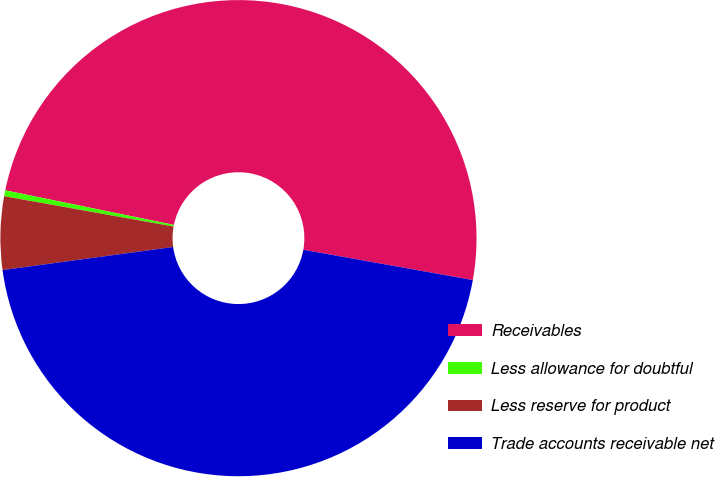<chart> <loc_0><loc_0><loc_500><loc_500><pie_chart><fcel>Receivables<fcel>Less allowance for doubtful<fcel>Less reserve for product<fcel>Trade accounts receivable net<nl><fcel>49.6%<fcel>0.4%<fcel>4.96%<fcel>45.04%<nl></chart> 